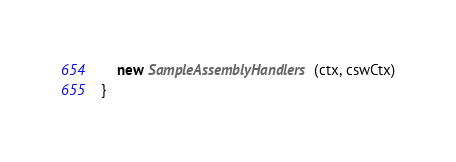Convert code to text. <code><loc_0><loc_0><loc_500><loc_500><_Scala_>    new SampleAssemblyHandlers(ctx, cswCtx)
}
</code> 